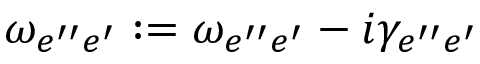Convert formula to latex. <formula><loc_0><loc_0><loc_500><loc_500>\omega _ { e ^ { \prime \prime } e ^ { \prime } } \colon = \omega _ { e ^ { \prime \prime } e ^ { \prime } } - i \gamma _ { e ^ { \prime \prime } e ^ { \prime } }</formula> 